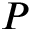<formula> <loc_0><loc_0><loc_500><loc_500>P</formula> 